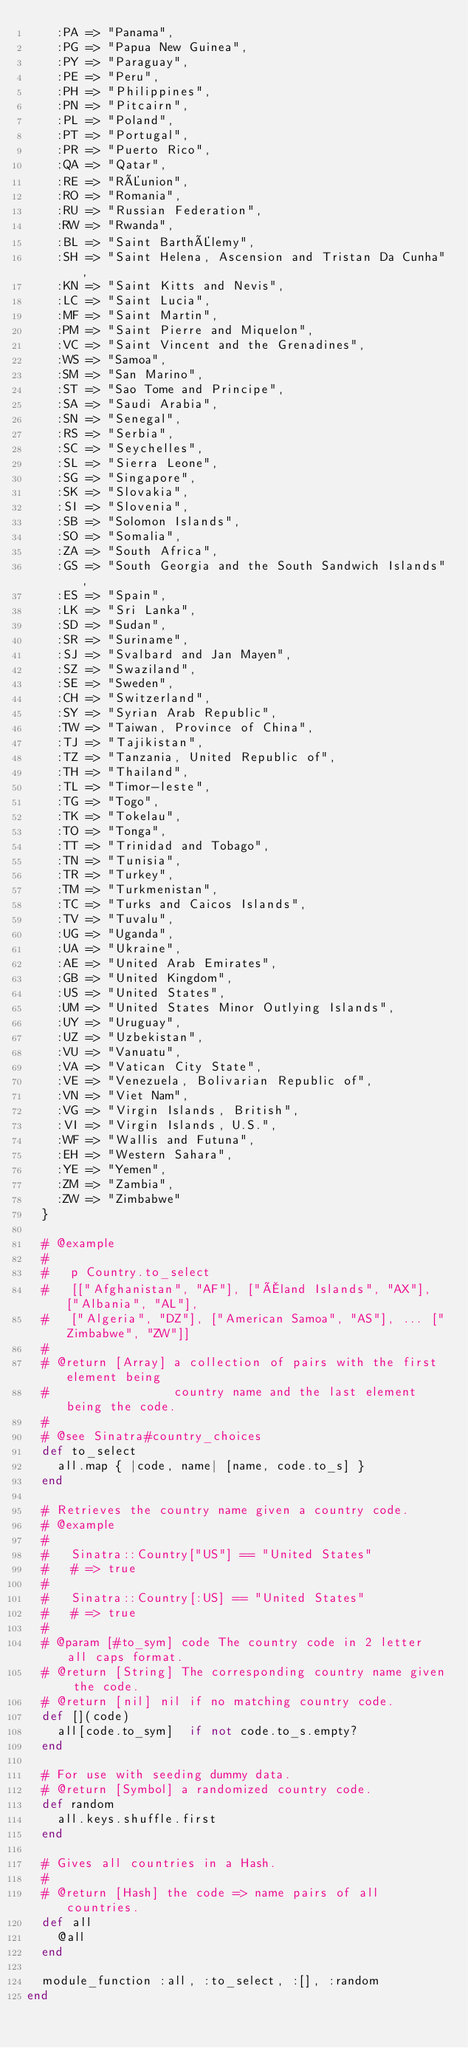Convert code to text. <code><loc_0><loc_0><loc_500><loc_500><_Ruby_>    :PA => "Panama",
    :PG => "Papua New Guinea",
    :PY => "Paraguay",
    :PE => "Peru",
    :PH => "Philippines",
    :PN => "Pitcairn",
    :PL => "Poland",
    :PT => "Portugal",
    :PR => "Puerto Rico",
    :QA => "Qatar",
    :RE => "RÉunion",
    :RO => "Romania",
    :RU => "Russian Federation",
    :RW => "Rwanda",
    :BL => "Saint BarthÉlemy",
    :SH => "Saint Helena, Ascension and Tristan Da Cunha",
    :KN => "Saint Kitts and Nevis",
    :LC => "Saint Lucia",
    :MF => "Saint Martin",
    :PM => "Saint Pierre and Miquelon",
    :VC => "Saint Vincent and the Grenadines",
    :WS => "Samoa",
    :SM => "San Marino",
    :ST => "Sao Tome and Principe",
    :SA => "Saudi Arabia",
    :SN => "Senegal",
    :RS => "Serbia",
    :SC => "Seychelles",
    :SL => "Sierra Leone",
    :SG => "Singapore",
    :SK => "Slovakia",
    :SI => "Slovenia",
    :SB => "Solomon Islands",
    :SO => "Somalia",
    :ZA => "South Africa",
    :GS => "South Georgia and the South Sandwich Islands",
    :ES => "Spain",
    :LK => "Sri Lanka",
    :SD => "Sudan",
    :SR => "Suriname",
    :SJ => "Svalbard and Jan Mayen",
    :SZ => "Swaziland",
    :SE => "Sweden",
    :CH => "Switzerland",
    :SY => "Syrian Arab Republic",
    :TW => "Taiwan, Province of China",
    :TJ => "Tajikistan",
    :TZ => "Tanzania, United Republic of",
    :TH => "Thailand",
    :TL => "Timor-leste",
    :TG => "Togo",
    :TK => "Tokelau",
    :TO => "Tonga",
    :TT => "Trinidad and Tobago",
    :TN => "Tunisia",
    :TR => "Turkey",
    :TM => "Turkmenistan",
    :TC => "Turks and Caicos Islands",
    :TV => "Tuvalu",
    :UG => "Uganda",
    :UA => "Ukraine",
    :AE => "United Arab Emirates",
    :GB => "United Kingdom",
    :US => "United States",
    :UM => "United States Minor Outlying Islands",
    :UY => "Uruguay",
    :UZ => "Uzbekistan",
    :VU => "Vanuatu",
    :VA => "Vatican City State",
    :VE => "Venezuela, Bolivarian Republic of",
    :VN => "Viet Nam",
    :VG => "Virgin Islands, British",
    :VI => "Virgin Islands, U.S.",
    :WF => "Wallis and Futuna",
    :EH => "Western Sahara",
    :YE => "Yemen",
    :ZM => "Zambia",
    :ZW => "Zimbabwe"
  }
  
  # @example
  #   
  #   p Country.to_select
  #   [["Afghanistan", "AF"], ["Åland Islands", "AX"], ["Albania", "AL"], 
  #   ["Algeria", "DZ"], ["American Samoa", "AS"], ... ["Zimbabwe", "ZW"]]
  #
  # @return [Array] a collection of pairs with the first element being 
  #                 country name and the last element being the code.
  #
  # @see Sinatra#country_choices
  def to_select
    all.map { |code, name| [name, code.to_s] }
  end
  
  # Retrieves the country name given a country code.
  # @example
  #   
  #   Sinatra::Country["US"] == "United States"
  #   # => true
  #
  #   Sinatra::Country[:US] == "United States"
  #   # => true
  #
  # @param [#to_sym] code The country code in 2 letter all caps format.
  # @return [String] The corresponding country name given the code.
  # @return [nil] nil if no matching country code.
  def [](code)
    all[code.to_sym]  if not code.to_s.empty?
  end
  
  # For use with seeding dummy data.
  # @return [Symbol] a randomized country code.
  def random
    all.keys.shuffle.first
  end
  
  # Gives all countries in a Hash.
  #
  # @return [Hash] the code => name pairs of all countries.
  def all
    @all
  end

  module_function :all, :to_select, :[], :random
end
</code> 